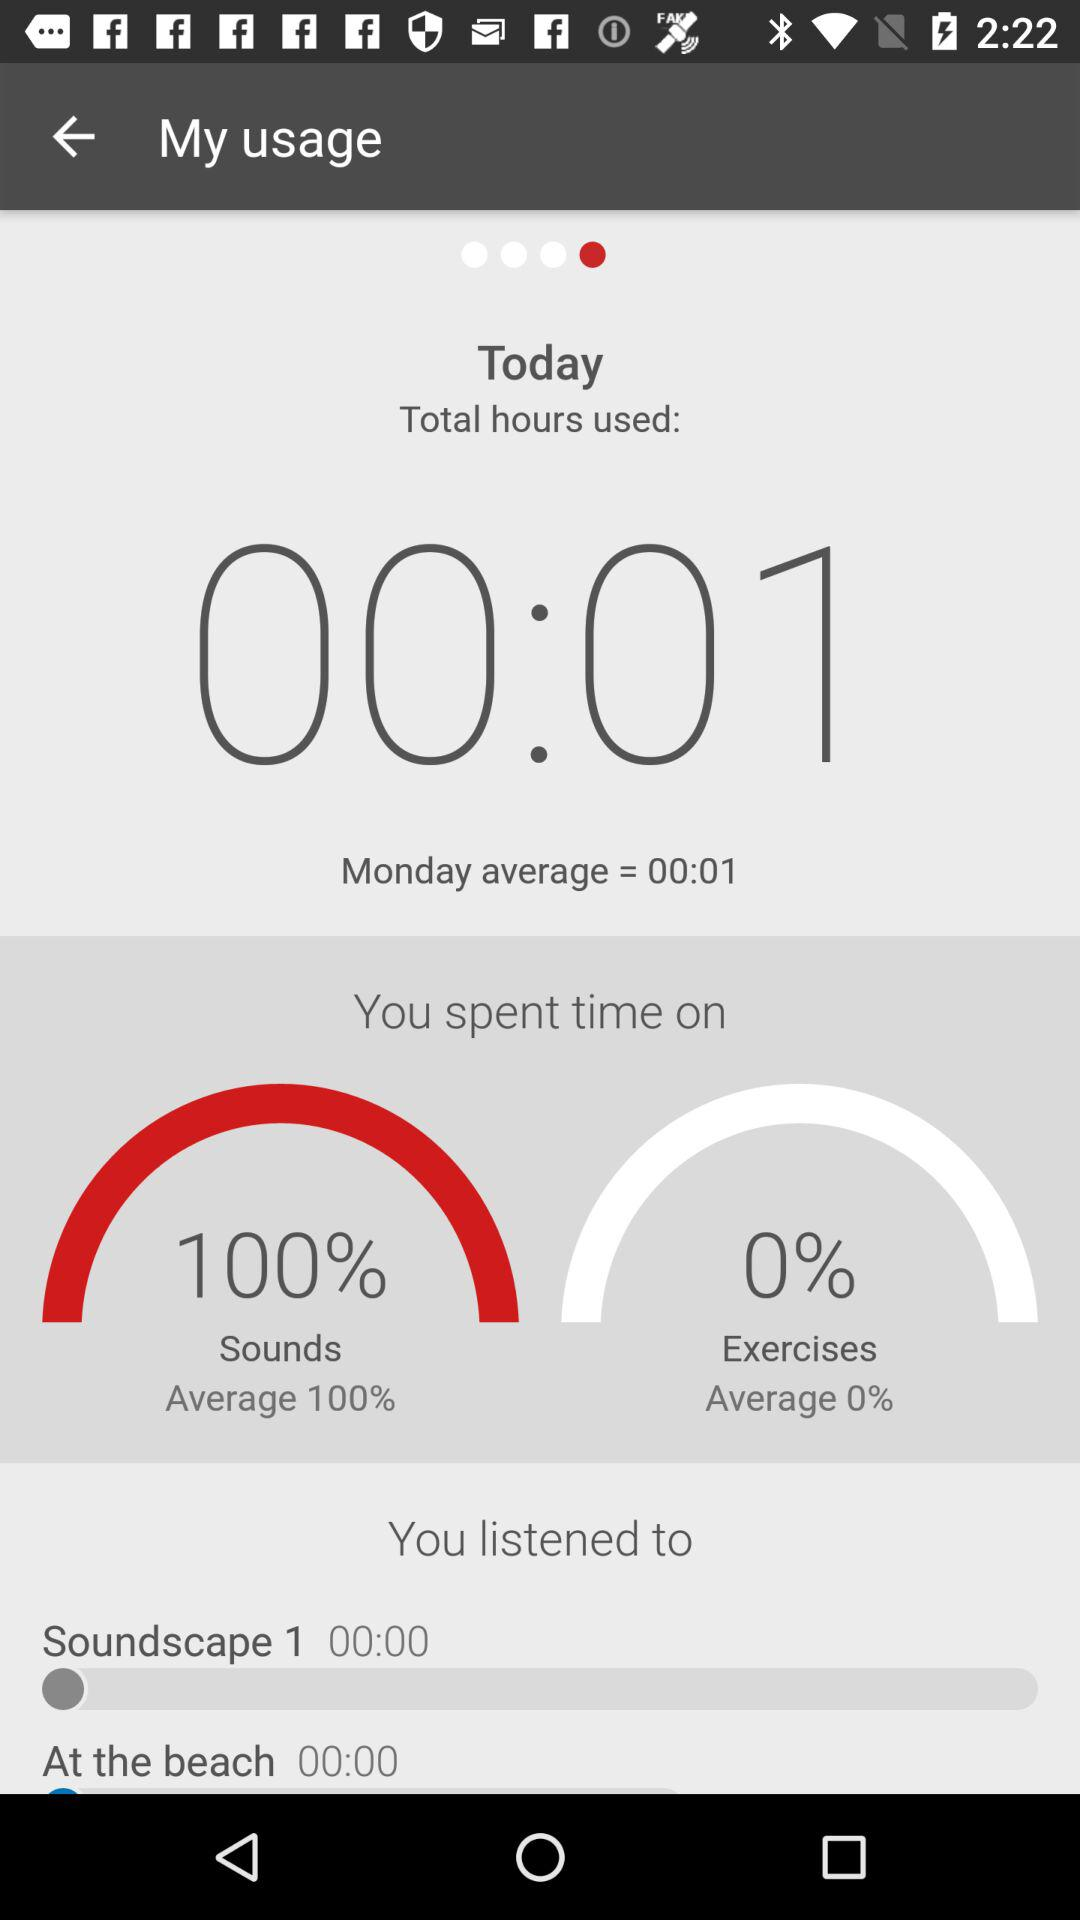What is the percentage of time spent on sounds compared to exercises?
Answer the question using a single word or phrase. 100% 